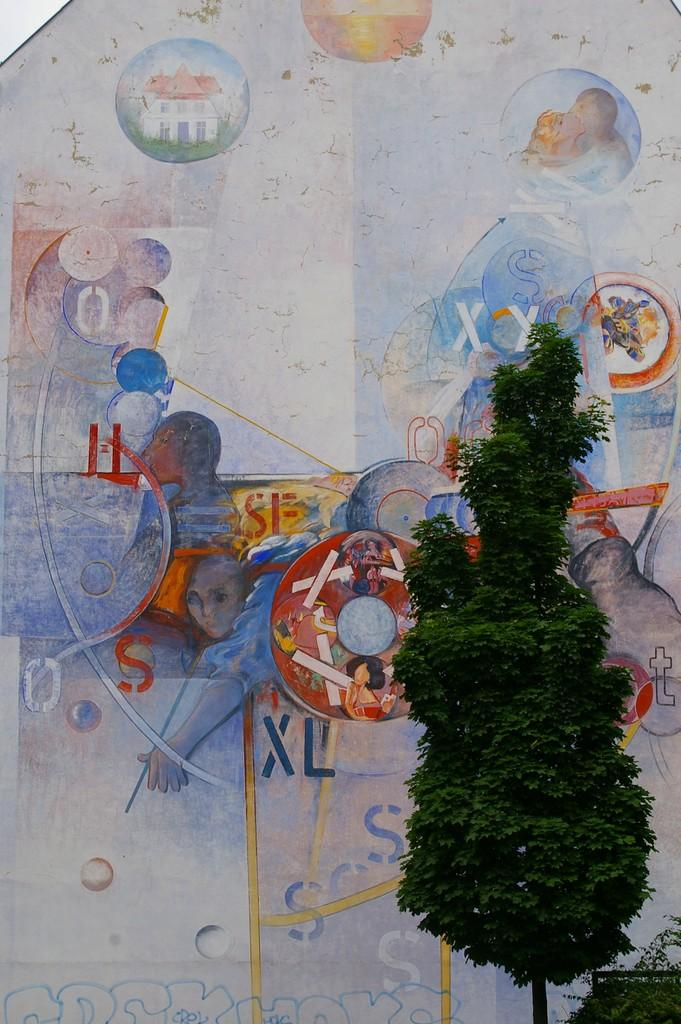What type of vegetation is on the right side of the image? There is a tree on the right side of the image. What can be seen on the wall in the background of the image? There appears to be a painting on the wall in the background of the image. Can you see any smoke coming from the tree in the image? There is no smoke present in the image; it features a tree and a painting on the wall. What color is the sock that the tree is wearing in the image? There is no sock present in the image, as trees do not wear socks. 